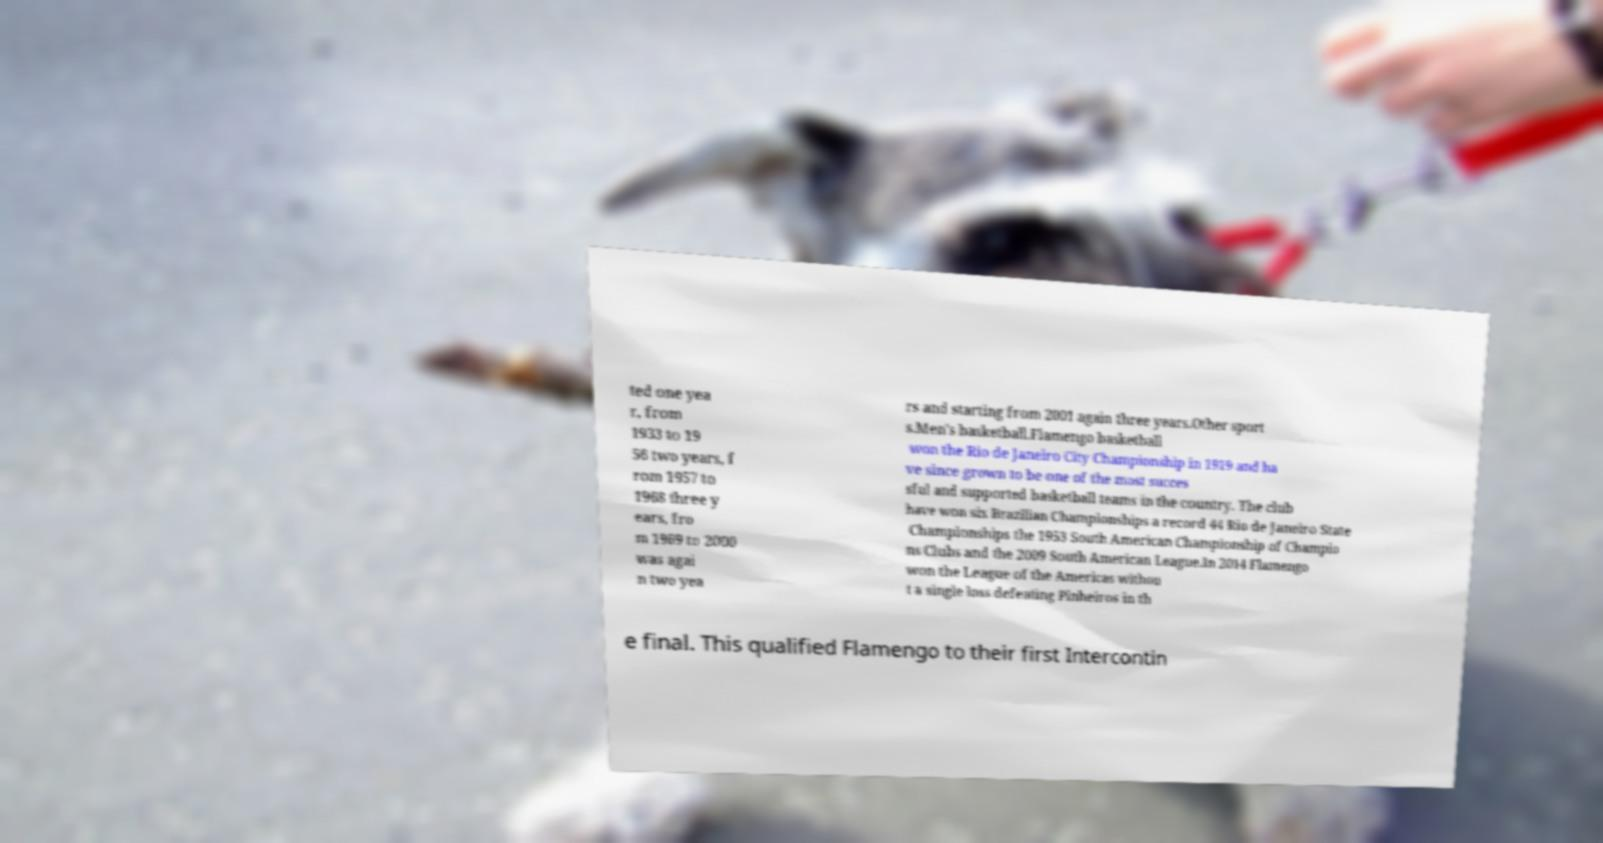What messages or text are displayed in this image? I need them in a readable, typed format. ted one yea r, from 1933 to 19 56 two years, f rom 1957 to 1968 three y ears, fro m 1969 to 2000 was agai n two yea rs and starting from 2001 again three years.Other sport s.Men's basketball.Flamengo basketball won the Rio de Janeiro City Championship in 1919 and ha ve since grown to be one of the most succes sful and supported basketball teams in the country. The club have won six Brazilian Championships a record 44 Rio de Janeiro State Championships the 1953 South American Championship of Champio ns Clubs and the 2009 South American League.In 2014 Flamengo won the League of the Americas withou t a single loss defeating Pinheiros in th e final. This qualified Flamengo to their first Intercontin 